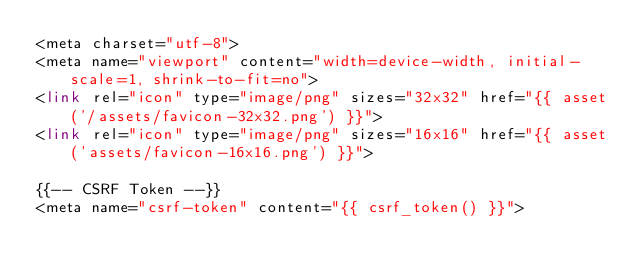Convert code to text. <code><loc_0><loc_0><loc_500><loc_500><_PHP_><meta charset="utf-8">
<meta name="viewport" content="width=device-width, initial-scale=1, shrink-to-fit=no">
<link rel="icon" type="image/png" sizes="32x32" href="{{ asset('/assets/favicon-32x32.png') }}">
<link rel="icon" type="image/png" sizes="16x16" href="{{ asset('assets/favicon-16x16.png') }}">

{{-- CSRF Token --}}
<meta name="csrf-token" content="{{ csrf_token() }}">
</code> 